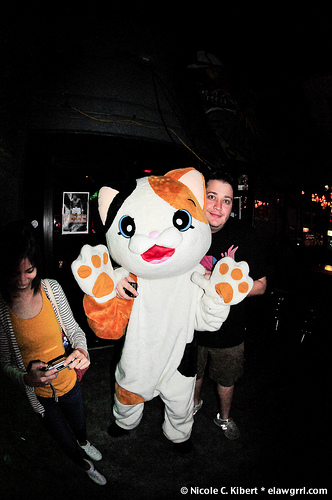<image>
Is the woman behind the cat? Yes. From this viewpoint, the woman is positioned behind the cat, with the cat partially or fully occluding the woman. Where is the person in relation to the cat? Is it behind the cat? No. The person is not behind the cat. From this viewpoint, the person appears to be positioned elsewhere in the scene. 